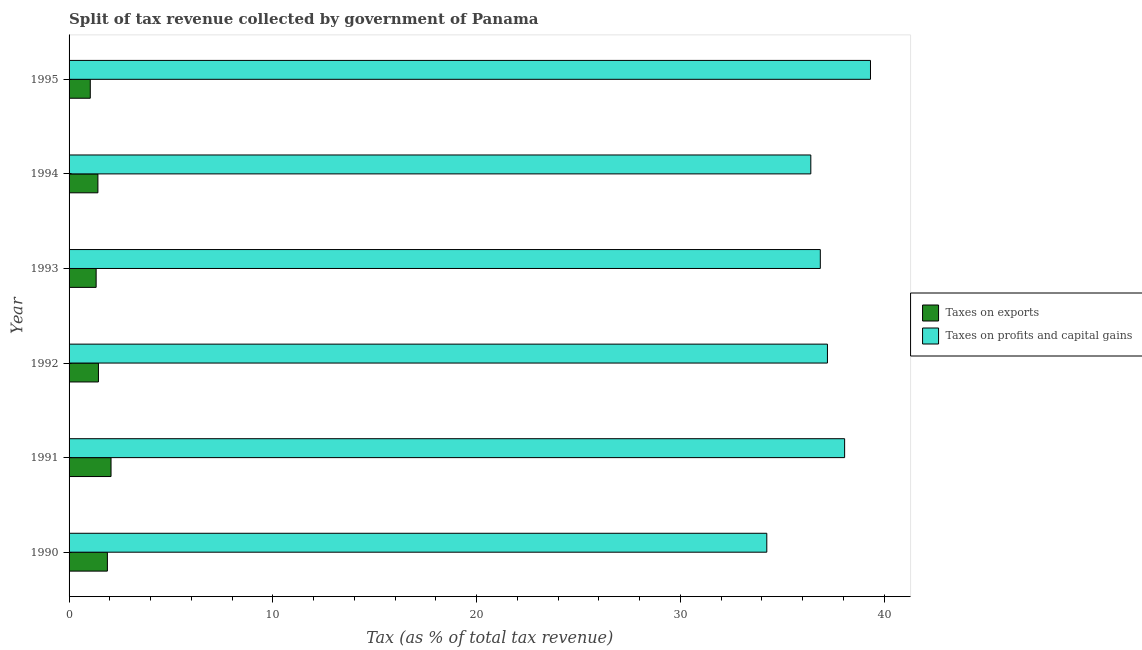How many different coloured bars are there?
Your answer should be very brief. 2. How many groups of bars are there?
Give a very brief answer. 6. Are the number of bars per tick equal to the number of legend labels?
Your answer should be very brief. Yes. Are the number of bars on each tick of the Y-axis equal?
Ensure brevity in your answer.  Yes. How many bars are there on the 5th tick from the top?
Keep it short and to the point. 2. How many bars are there on the 6th tick from the bottom?
Offer a very short reply. 2. What is the percentage of revenue obtained from taxes on profits and capital gains in 1993?
Give a very brief answer. 36.86. Across all years, what is the maximum percentage of revenue obtained from taxes on exports?
Your answer should be very brief. 2.06. Across all years, what is the minimum percentage of revenue obtained from taxes on profits and capital gains?
Your response must be concise. 34.24. In which year was the percentage of revenue obtained from taxes on exports minimum?
Offer a terse response. 1995. What is the total percentage of revenue obtained from taxes on exports in the graph?
Your answer should be very brief. 9.17. What is the difference between the percentage of revenue obtained from taxes on profits and capital gains in 1991 and that in 1993?
Give a very brief answer. 1.19. What is the difference between the percentage of revenue obtained from taxes on exports in 1990 and the percentage of revenue obtained from taxes on profits and capital gains in 1993?
Your answer should be compact. -34.98. What is the average percentage of revenue obtained from taxes on exports per year?
Give a very brief answer. 1.53. In the year 1990, what is the difference between the percentage of revenue obtained from taxes on profits and capital gains and percentage of revenue obtained from taxes on exports?
Ensure brevity in your answer.  32.36. In how many years, is the percentage of revenue obtained from taxes on profits and capital gains greater than 12 %?
Give a very brief answer. 6. What is the ratio of the percentage of revenue obtained from taxes on profits and capital gains in 1992 to that in 1993?
Your answer should be very brief. 1.01. What is the difference between the highest and the second highest percentage of revenue obtained from taxes on profits and capital gains?
Offer a very short reply. 1.27. What is the difference between the highest and the lowest percentage of revenue obtained from taxes on profits and capital gains?
Ensure brevity in your answer.  5.09. In how many years, is the percentage of revenue obtained from taxes on profits and capital gains greater than the average percentage of revenue obtained from taxes on profits and capital gains taken over all years?
Provide a succinct answer. 3. Is the sum of the percentage of revenue obtained from taxes on exports in 1994 and 1995 greater than the maximum percentage of revenue obtained from taxes on profits and capital gains across all years?
Your response must be concise. No. What does the 2nd bar from the top in 1993 represents?
Give a very brief answer. Taxes on exports. What does the 2nd bar from the bottom in 1991 represents?
Ensure brevity in your answer.  Taxes on profits and capital gains. How many years are there in the graph?
Give a very brief answer. 6. What is the difference between two consecutive major ticks on the X-axis?
Offer a terse response. 10. Where does the legend appear in the graph?
Keep it short and to the point. Center right. How many legend labels are there?
Offer a terse response. 2. What is the title of the graph?
Offer a terse response. Split of tax revenue collected by government of Panama. Does "Investment in Transport" appear as one of the legend labels in the graph?
Your answer should be very brief. No. What is the label or title of the X-axis?
Provide a short and direct response. Tax (as % of total tax revenue). What is the label or title of the Y-axis?
Give a very brief answer. Year. What is the Tax (as % of total tax revenue) in Taxes on exports in 1990?
Your response must be concise. 1.88. What is the Tax (as % of total tax revenue) of Taxes on profits and capital gains in 1990?
Offer a terse response. 34.24. What is the Tax (as % of total tax revenue) in Taxes on exports in 1991?
Your answer should be compact. 2.06. What is the Tax (as % of total tax revenue) in Taxes on profits and capital gains in 1991?
Provide a short and direct response. 38.06. What is the Tax (as % of total tax revenue) in Taxes on exports in 1992?
Your answer should be very brief. 1.44. What is the Tax (as % of total tax revenue) of Taxes on profits and capital gains in 1992?
Offer a very short reply. 37.21. What is the Tax (as % of total tax revenue) of Taxes on exports in 1993?
Offer a terse response. 1.33. What is the Tax (as % of total tax revenue) in Taxes on profits and capital gains in 1993?
Give a very brief answer. 36.86. What is the Tax (as % of total tax revenue) in Taxes on exports in 1994?
Your answer should be very brief. 1.41. What is the Tax (as % of total tax revenue) in Taxes on profits and capital gains in 1994?
Offer a terse response. 36.4. What is the Tax (as % of total tax revenue) in Taxes on exports in 1995?
Make the answer very short. 1.04. What is the Tax (as % of total tax revenue) of Taxes on profits and capital gains in 1995?
Offer a terse response. 39.33. Across all years, what is the maximum Tax (as % of total tax revenue) in Taxes on exports?
Your response must be concise. 2.06. Across all years, what is the maximum Tax (as % of total tax revenue) of Taxes on profits and capital gains?
Give a very brief answer. 39.33. Across all years, what is the minimum Tax (as % of total tax revenue) of Taxes on exports?
Ensure brevity in your answer.  1.04. Across all years, what is the minimum Tax (as % of total tax revenue) of Taxes on profits and capital gains?
Provide a short and direct response. 34.24. What is the total Tax (as % of total tax revenue) of Taxes on exports in the graph?
Your answer should be compact. 9.17. What is the total Tax (as % of total tax revenue) in Taxes on profits and capital gains in the graph?
Offer a terse response. 222.1. What is the difference between the Tax (as % of total tax revenue) in Taxes on exports in 1990 and that in 1991?
Your answer should be compact. -0.18. What is the difference between the Tax (as % of total tax revenue) in Taxes on profits and capital gains in 1990 and that in 1991?
Your answer should be compact. -3.82. What is the difference between the Tax (as % of total tax revenue) in Taxes on exports in 1990 and that in 1992?
Provide a succinct answer. 0.44. What is the difference between the Tax (as % of total tax revenue) in Taxes on profits and capital gains in 1990 and that in 1992?
Give a very brief answer. -2.98. What is the difference between the Tax (as % of total tax revenue) of Taxes on exports in 1990 and that in 1993?
Your answer should be very brief. 0.55. What is the difference between the Tax (as % of total tax revenue) in Taxes on profits and capital gains in 1990 and that in 1993?
Ensure brevity in your answer.  -2.63. What is the difference between the Tax (as % of total tax revenue) in Taxes on exports in 1990 and that in 1994?
Offer a very short reply. 0.47. What is the difference between the Tax (as % of total tax revenue) in Taxes on profits and capital gains in 1990 and that in 1994?
Provide a short and direct response. -2.16. What is the difference between the Tax (as % of total tax revenue) of Taxes on exports in 1990 and that in 1995?
Make the answer very short. 0.84. What is the difference between the Tax (as % of total tax revenue) of Taxes on profits and capital gains in 1990 and that in 1995?
Give a very brief answer. -5.09. What is the difference between the Tax (as % of total tax revenue) of Taxes on exports in 1991 and that in 1992?
Keep it short and to the point. 0.62. What is the difference between the Tax (as % of total tax revenue) of Taxes on profits and capital gains in 1991 and that in 1992?
Provide a short and direct response. 0.84. What is the difference between the Tax (as % of total tax revenue) of Taxes on exports in 1991 and that in 1993?
Give a very brief answer. 0.73. What is the difference between the Tax (as % of total tax revenue) in Taxes on profits and capital gains in 1991 and that in 1993?
Keep it short and to the point. 1.19. What is the difference between the Tax (as % of total tax revenue) of Taxes on exports in 1991 and that in 1994?
Your answer should be very brief. 0.64. What is the difference between the Tax (as % of total tax revenue) of Taxes on profits and capital gains in 1991 and that in 1994?
Your response must be concise. 1.66. What is the difference between the Tax (as % of total tax revenue) in Taxes on exports in 1991 and that in 1995?
Your response must be concise. 1.02. What is the difference between the Tax (as % of total tax revenue) in Taxes on profits and capital gains in 1991 and that in 1995?
Offer a very short reply. -1.27. What is the difference between the Tax (as % of total tax revenue) in Taxes on exports in 1992 and that in 1993?
Provide a short and direct response. 0.11. What is the difference between the Tax (as % of total tax revenue) in Taxes on profits and capital gains in 1992 and that in 1993?
Give a very brief answer. 0.35. What is the difference between the Tax (as % of total tax revenue) in Taxes on exports in 1992 and that in 1994?
Your answer should be compact. 0.03. What is the difference between the Tax (as % of total tax revenue) in Taxes on profits and capital gains in 1992 and that in 1994?
Give a very brief answer. 0.82. What is the difference between the Tax (as % of total tax revenue) of Taxes on exports in 1992 and that in 1995?
Your response must be concise. 0.4. What is the difference between the Tax (as % of total tax revenue) in Taxes on profits and capital gains in 1992 and that in 1995?
Offer a very short reply. -2.11. What is the difference between the Tax (as % of total tax revenue) in Taxes on exports in 1993 and that in 1994?
Your answer should be compact. -0.09. What is the difference between the Tax (as % of total tax revenue) of Taxes on profits and capital gains in 1993 and that in 1994?
Provide a short and direct response. 0.47. What is the difference between the Tax (as % of total tax revenue) of Taxes on exports in 1993 and that in 1995?
Provide a short and direct response. 0.29. What is the difference between the Tax (as % of total tax revenue) in Taxes on profits and capital gains in 1993 and that in 1995?
Offer a terse response. -2.46. What is the difference between the Tax (as % of total tax revenue) of Taxes on exports in 1994 and that in 1995?
Provide a short and direct response. 0.37. What is the difference between the Tax (as % of total tax revenue) in Taxes on profits and capital gains in 1994 and that in 1995?
Provide a short and direct response. -2.93. What is the difference between the Tax (as % of total tax revenue) in Taxes on exports in 1990 and the Tax (as % of total tax revenue) in Taxes on profits and capital gains in 1991?
Offer a terse response. -36.18. What is the difference between the Tax (as % of total tax revenue) of Taxes on exports in 1990 and the Tax (as % of total tax revenue) of Taxes on profits and capital gains in 1992?
Give a very brief answer. -35.33. What is the difference between the Tax (as % of total tax revenue) of Taxes on exports in 1990 and the Tax (as % of total tax revenue) of Taxes on profits and capital gains in 1993?
Your answer should be very brief. -34.98. What is the difference between the Tax (as % of total tax revenue) of Taxes on exports in 1990 and the Tax (as % of total tax revenue) of Taxes on profits and capital gains in 1994?
Your answer should be very brief. -34.52. What is the difference between the Tax (as % of total tax revenue) in Taxes on exports in 1990 and the Tax (as % of total tax revenue) in Taxes on profits and capital gains in 1995?
Your response must be concise. -37.45. What is the difference between the Tax (as % of total tax revenue) of Taxes on exports in 1991 and the Tax (as % of total tax revenue) of Taxes on profits and capital gains in 1992?
Offer a very short reply. -35.16. What is the difference between the Tax (as % of total tax revenue) of Taxes on exports in 1991 and the Tax (as % of total tax revenue) of Taxes on profits and capital gains in 1993?
Your response must be concise. -34.81. What is the difference between the Tax (as % of total tax revenue) of Taxes on exports in 1991 and the Tax (as % of total tax revenue) of Taxes on profits and capital gains in 1994?
Offer a very short reply. -34.34. What is the difference between the Tax (as % of total tax revenue) in Taxes on exports in 1991 and the Tax (as % of total tax revenue) in Taxes on profits and capital gains in 1995?
Offer a very short reply. -37.27. What is the difference between the Tax (as % of total tax revenue) of Taxes on exports in 1992 and the Tax (as % of total tax revenue) of Taxes on profits and capital gains in 1993?
Your response must be concise. -35.42. What is the difference between the Tax (as % of total tax revenue) in Taxes on exports in 1992 and the Tax (as % of total tax revenue) in Taxes on profits and capital gains in 1994?
Make the answer very short. -34.96. What is the difference between the Tax (as % of total tax revenue) of Taxes on exports in 1992 and the Tax (as % of total tax revenue) of Taxes on profits and capital gains in 1995?
Offer a terse response. -37.89. What is the difference between the Tax (as % of total tax revenue) in Taxes on exports in 1993 and the Tax (as % of total tax revenue) in Taxes on profits and capital gains in 1994?
Ensure brevity in your answer.  -35.07. What is the difference between the Tax (as % of total tax revenue) in Taxes on exports in 1993 and the Tax (as % of total tax revenue) in Taxes on profits and capital gains in 1995?
Your answer should be very brief. -38. What is the difference between the Tax (as % of total tax revenue) of Taxes on exports in 1994 and the Tax (as % of total tax revenue) of Taxes on profits and capital gains in 1995?
Provide a short and direct response. -37.91. What is the average Tax (as % of total tax revenue) in Taxes on exports per year?
Your answer should be very brief. 1.53. What is the average Tax (as % of total tax revenue) in Taxes on profits and capital gains per year?
Your answer should be very brief. 37.02. In the year 1990, what is the difference between the Tax (as % of total tax revenue) of Taxes on exports and Tax (as % of total tax revenue) of Taxes on profits and capital gains?
Your answer should be very brief. -32.36. In the year 1991, what is the difference between the Tax (as % of total tax revenue) of Taxes on exports and Tax (as % of total tax revenue) of Taxes on profits and capital gains?
Make the answer very short. -36. In the year 1992, what is the difference between the Tax (as % of total tax revenue) of Taxes on exports and Tax (as % of total tax revenue) of Taxes on profits and capital gains?
Keep it short and to the point. -35.77. In the year 1993, what is the difference between the Tax (as % of total tax revenue) of Taxes on exports and Tax (as % of total tax revenue) of Taxes on profits and capital gains?
Your answer should be compact. -35.54. In the year 1994, what is the difference between the Tax (as % of total tax revenue) of Taxes on exports and Tax (as % of total tax revenue) of Taxes on profits and capital gains?
Ensure brevity in your answer.  -34.98. In the year 1995, what is the difference between the Tax (as % of total tax revenue) in Taxes on exports and Tax (as % of total tax revenue) in Taxes on profits and capital gains?
Ensure brevity in your answer.  -38.29. What is the ratio of the Tax (as % of total tax revenue) of Taxes on exports in 1990 to that in 1991?
Make the answer very short. 0.91. What is the ratio of the Tax (as % of total tax revenue) of Taxes on profits and capital gains in 1990 to that in 1991?
Your response must be concise. 0.9. What is the ratio of the Tax (as % of total tax revenue) of Taxes on exports in 1990 to that in 1992?
Your answer should be very brief. 1.3. What is the ratio of the Tax (as % of total tax revenue) of Taxes on exports in 1990 to that in 1993?
Your response must be concise. 1.42. What is the ratio of the Tax (as % of total tax revenue) in Taxes on profits and capital gains in 1990 to that in 1993?
Provide a succinct answer. 0.93. What is the ratio of the Tax (as % of total tax revenue) of Taxes on exports in 1990 to that in 1994?
Provide a short and direct response. 1.33. What is the ratio of the Tax (as % of total tax revenue) in Taxes on profits and capital gains in 1990 to that in 1994?
Keep it short and to the point. 0.94. What is the ratio of the Tax (as % of total tax revenue) in Taxes on exports in 1990 to that in 1995?
Make the answer very short. 1.81. What is the ratio of the Tax (as % of total tax revenue) in Taxes on profits and capital gains in 1990 to that in 1995?
Your answer should be very brief. 0.87. What is the ratio of the Tax (as % of total tax revenue) in Taxes on exports in 1991 to that in 1992?
Offer a terse response. 1.43. What is the ratio of the Tax (as % of total tax revenue) of Taxes on profits and capital gains in 1991 to that in 1992?
Offer a very short reply. 1.02. What is the ratio of the Tax (as % of total tax revenue) of Taxes on exports in 1991 to that in 1993?
Your response must be concise. 1.55. What is the ratio of the Tax (as % of total tax revenue) in Taxes on profits and capital gains in 1991 to that in 1993?
Ensure brevity in your answer.  1.03. What is the ratio of the Tax (as % of total tax revenue) in Taxes on exports in 1991 to that in 1994?
Keep it short and to the point. 1.46. What is the ratio of the Tax (as % of total tax revenue) of Taxes on profits and capital gains in 1991 to that in 1994?
Keep it short and to the point. 1.05. What is the ratio of the Tax (as % of total tax revenue) in Taxes on exports in 1991 to that in 1995?
Provide a succinct answer. 1.98. What is the ratio of the Tax (as % of total tax revenue) in Taxes on profits and capital gains in 1991 to that in 1995?
Your answer should be very brief. 0.97. What is the ratio of the Tax (as % of total tax revenue) of Taxes on exports in 1992 to that in 1993?
Ensure brevity in your answer.  1.08. What is the ratio of the Tax (as % of total tax revenue) of Taxes on profits and capital gains in 1992 to that in 1993?
Give a very brief answer. 1.01. What is the ratio of the Tax (as % of total tax revenue) of Taxes on exports in 1992 to that in 1994?
Your response must be concise. 1.02. What is the ratio of the Tax (as % of total tax revenue) in Taxes on profits and capital gains in 1992 to that in 1994?
Keep it short and to the point. 1.02. What is the ratio of the Tax (as % of total tax revenue) of Taxes on exports in 1992 to that in 1995?
Keep it short and to the point. 1.38. What is the ratio of the Tax (as % of total tax revenue) in Taxes on profits and capital gains in 1992 to that in 1995?
Offer a very short reply. 0.95. What is the ratio of the Tax (as % of total tax revenue) in Taxes on exports in 1993 to that in 1994?
Your answer should be very brief. 0.94. What is the ratio of the Tax (as % of total tax revenue) of Taxes on profits and capital gains in 1993 to that in 1994?
Keep it short and to the point. 1.01. What is the ratio of the Tax (as % of total tax revenue) in Taxes on exports in 1993 to that in 1995?
Offer a very short reply. 1.28. What is the ratio of the Tax (as % of total tax revenue) of Taxes on profits and capital gains in 1993 to that in 1995?
Offer a very short reply. 0.94. What is the ratio of the Tax (as % of total tax revenue) in Taxes on exports in 1994 to that in 1995?
Offer a terse response. 1.36. What is the ratio of the Tax (as % of total tax revenue) in Taxes on profits and capital gains in 1994 to that in 1995?
Provide a succinct answer. 0.93. What is the difference between the highest and the second highest Tax (as % of total tax revenue) of Taxes on exports?
Keep it short and to the point. 0.18. What is the difference between the highest and the second highest Tax (as % of total tax revenue) of Taxes on profits and capital gains?
Offer a terse response. 1.27. What is the difference between the highest and the lowest Tax (as % of total tax revenue) of Taxes on exports?
Keep it short and to the point. 1.02. What is the difference between the highest and the lowest Tax (as % of total tax revenue) in Taxes on profits and capital gains?
Offer a very short reply. 5.09. 